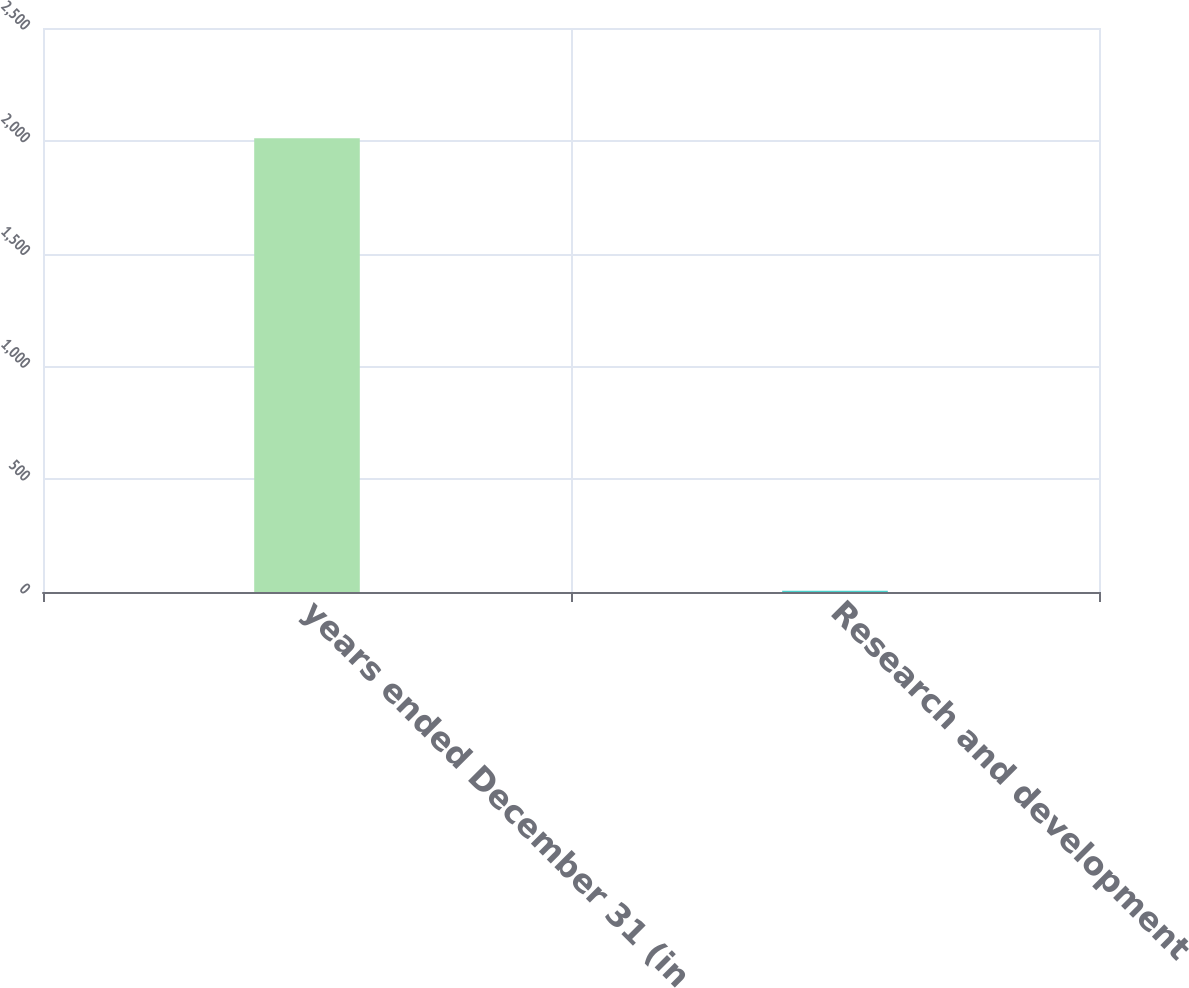Convert chart to OTSL. <chart><loc_0><loc_0><loc_500><loc_500><bar_chart><fcel>years ended December 31 (in<fcel>Research and development<nl><fcel>2011<fcel>5<nl></chart> 